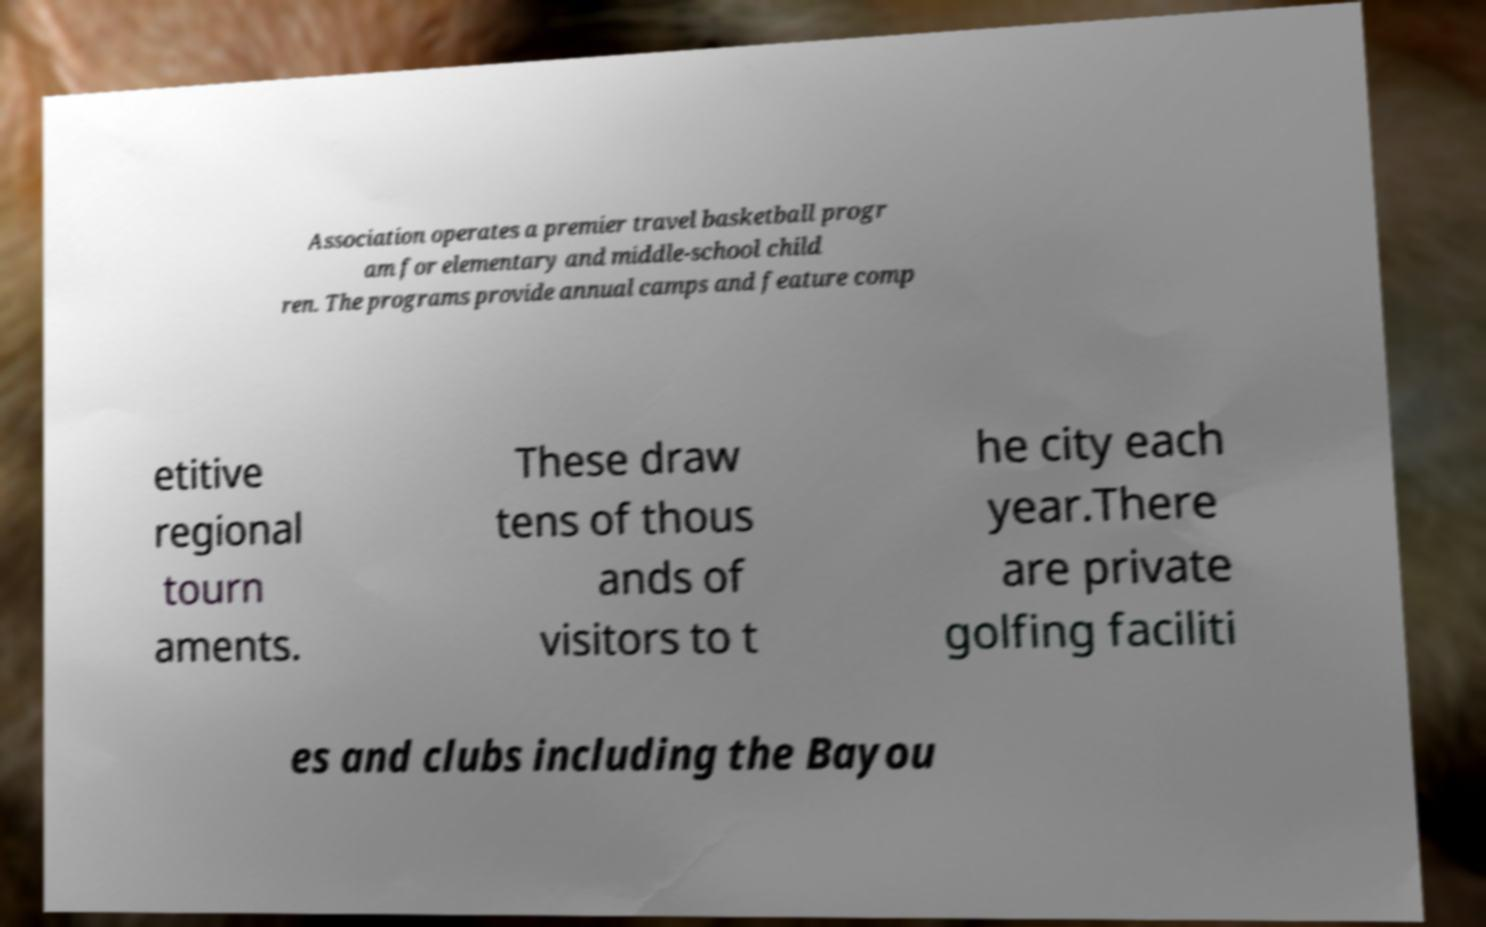Can you read and provide the text displayed in the image?This photo seems to have some interesting text. Can you extract and type it out for me? Association operates a premier travel basketball progr am for elementary and middle-school child ren. The programs provide annual camps and feature comp etitive regional tourn aments. These draw tens of thous ands of visitors to t he city each year.There are private golfing faciliti es and clubs including the Bayou 